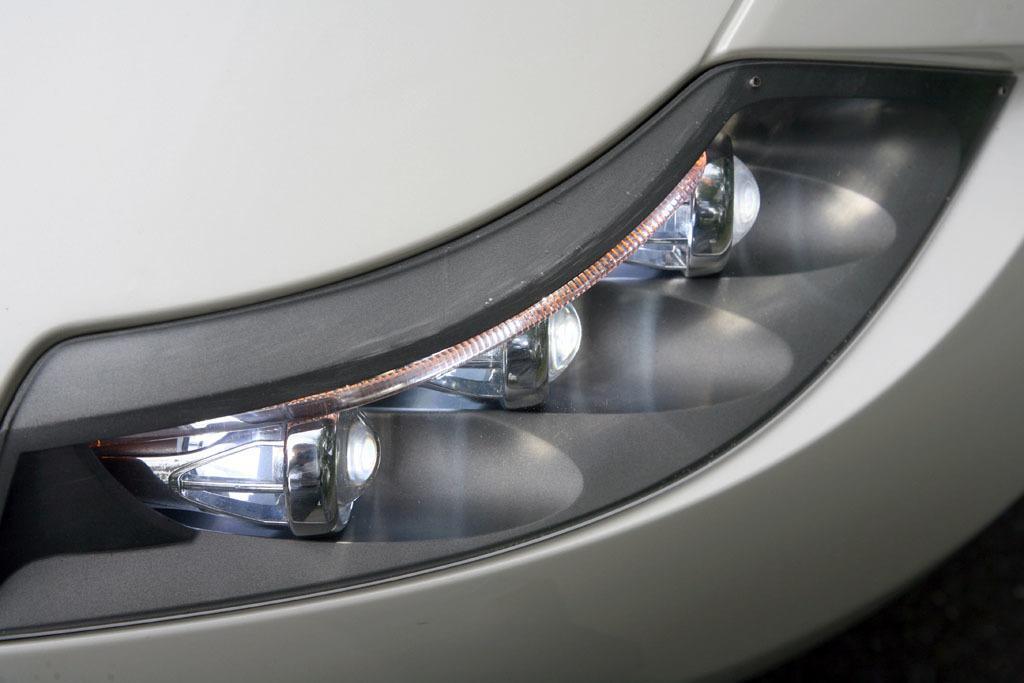Could you give a brief overview of what you see in this image? In this image I can see a vehicle which is grey in color and its headlight which is black and white in color. 